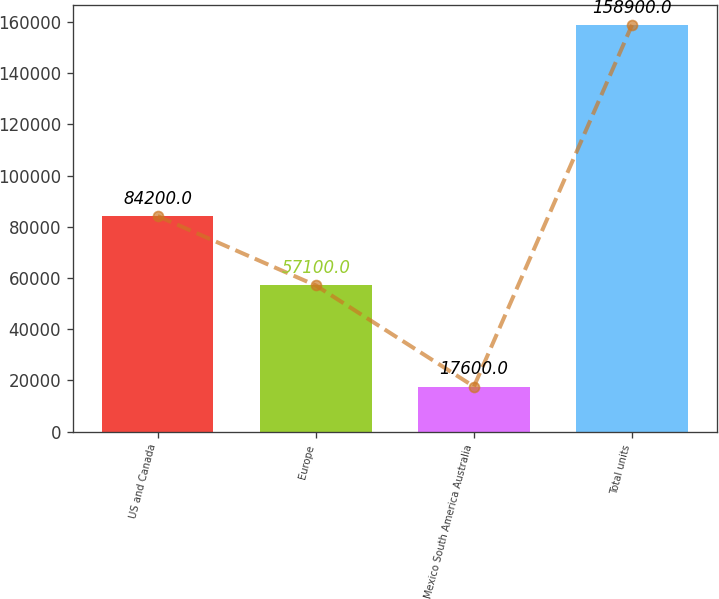Convert chart to OTSL. <chart><loc_0><loc_0><loc_500><loc_500><bar_chart><fcel>US and Canada<fcel>Europe<fcel>Mexico South America Australia<fcel>Total units<nl><fcel>84200<fcel>57100<fcel>17600<fcel>158900<nl></chart> 